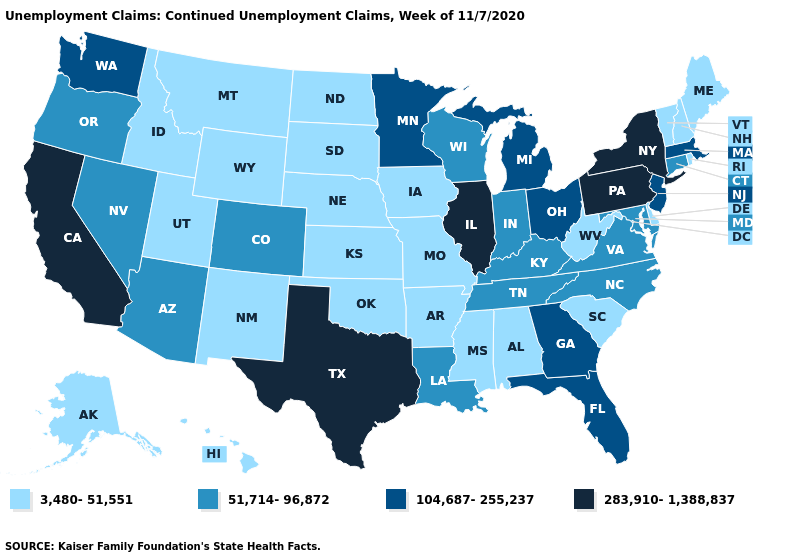Name the states that have a value in the range 3,480-51,551?
Short answer required. Alabama, Alaska, Arkansas, Delaware, Hawaii, Idaho, Iowa, Kansas, Maine, Mississippi, Missouri, Montana, Nebraska, New Hampshire, New Mexico, North Dakota, Oklahoma, Rhode Island, South Carolina, South Dakota, Utah, Vermont, West Virginia, Wyoming. Does the map have missing data?
Quick response, please. No. What is the highest value in states that border Kentucky?
Quick response, please. 283,910-1,388,837. What is the value of Wyoming?
Short answer required. 3,480-51,551. Name the states that have a value in the range 51,714-96,872?
Short answer required. Arizona, Colorado, Connecticut, Indiana, Kentucky, Louisiana, Maryland, Nevada, North Carolina, Oregon, Tennessee, Virginia, Wisconsin. Which states have the lowest value in the USA?
Write a very short answer. Alabama, Alaska, Arkansas, Delaware, Hawaii, Idaho, Iowa, Kansas, Maine, Mississippi, Missouri, Montana, Nebraska, New Hampshire, New Mexico, North Dakota, Oklahoma, Rhode Island, South Carolina, South Dakota, Utah, Vermont, West Virginia, Wyoming. Is the legend a continuous bar?
Write a very short answer. No. What is the value of Illinois?
Concise answer only. 283,910-1,388,837. Is the legend a continuous bar?
Keep it brief. No. What is the value of Idaho?
Answer briefly. 3,480-51,551. What is the lowest value in the MidWest?
Write a very short answer. 3,480-51,551. Does Mississippi have the lowest value in the USA?
Short answer required. Yes. Name the states that have a value in the range 51,714-96,872?
Write a very short answer. Arizona, Colorado, Connecticut, Indiana, Kentucky, Louisiana, Maryland, Nevada, North Carolina, Oregon, Tennessee, Virginia, Wisconsin. Does Illinois have the same value as Pennsylvania?
Be succinct. Yes. What is the highest value in the MidWest ?
Answer briefly. 283,910-1,388,837. 